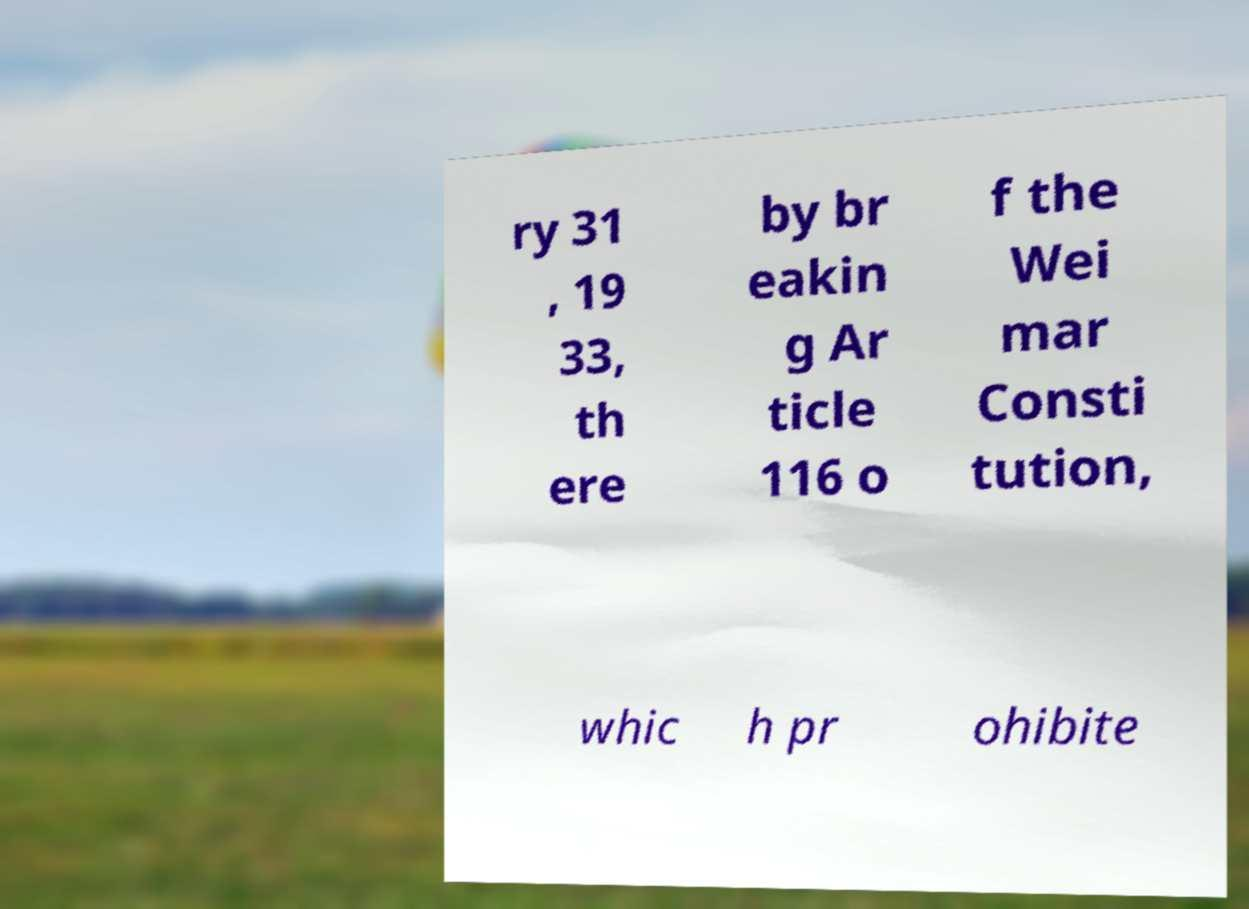What messages or text are displayed in this image? I need them in a readable, typed format. ry 31 , 19 33, th ere by br eakin g Ar ticle 116 o f the Wei mar Consti tution, whic h pr ohibite 